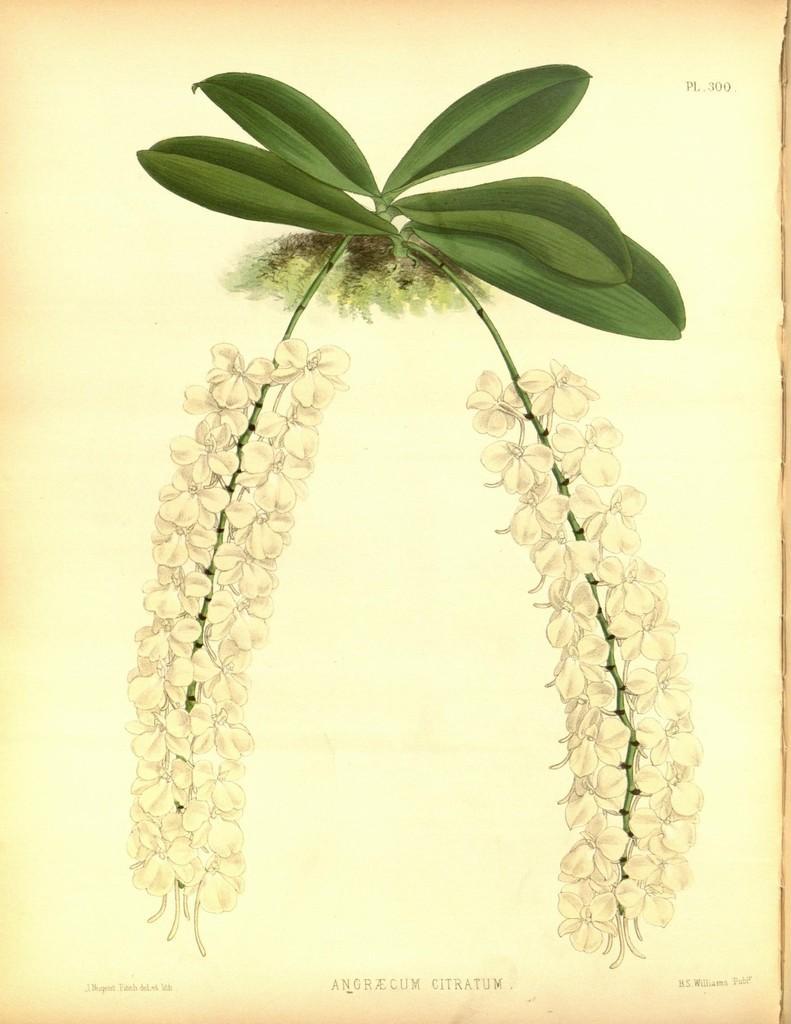Can you describe this image briefly? In this picture there is a white color paper poster with green leaves drawn on it. 